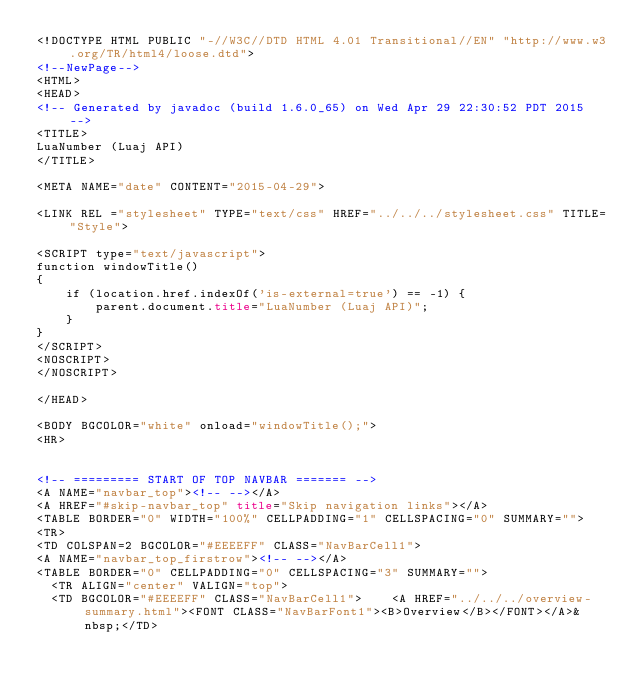Convert code to text. <code><loc_0><loc_0><loc_500><loc_500><_HTML_><!DOCTYPE HTML PUBLIC "-//W3C//DTD HTML 4.01 Transitional//EN" "http://www.w3.org/TR/html4/loose.dtd">
<!--NewPage-->
<HTML>
<HEAD>
<!-- Generated by javadoc (build 1.6.0_65) on Wed Apr 29 22:30:52 PDT 2015 -->
<TITLE>
LuaNumber (Luaj API)
</TITLE>

<META NAME="date" CONTENT="2015-04-29">

<LINK REL ="stylesheet" TYPE="text/css" HREF="../../../stylesheet.css" TITLE="Style">

<SCRIPT type="text/javascript">
function windowTitle()
{
    if (location.href.indexOf('is-external=true') == -1) {
        parent.document.title="LuaNumber (Luaj API)";
    }
}
</SCRIPT>
<NOSCRIPT>
</NOSCRIPT>

</HEAD>

<BODY BGCOLOR="white" onload="windowTitle();">
<HR>


<!-- ========= START OF TOP NAVBAR ======= -->
<A NAME="navbar_top"><!-- --></A>
<A HREF="#skip-navbar_top" title="Skip navigation links"></A>
<TABLE BORDER="0" WIDTH="100%" CELLPADDING="1" CELLSPACING="0" SUMMARY="">
<TR>
<TD COLSPAN=2 BGCOLOR="#EEEEFF" CLASS="NavBarCell1">
<A NAME="navbar_top_firstrow"><!-- --></A>
<TABLE BORDER="0" CELLPADDING="0" CELLSPACING="3" SUMMARY="">
  <TR ALIGN="center" VALIGN="top">
  <TD BGCOLOR="#EEEEFF" CLASS="NavBarCell1">    <A HREF="../../../overview-summary.html"><FONT CLASS="NavBarFont1"><B>Overview</B></FONT></A>&nbsp;</TD></code> 